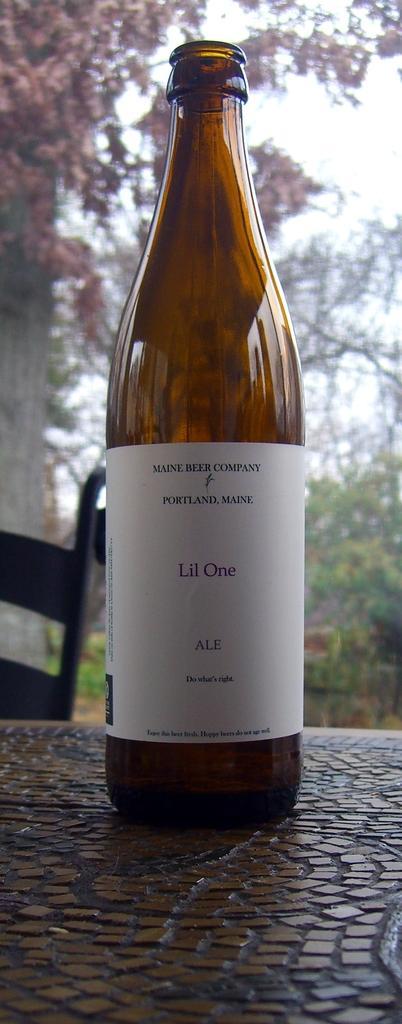Could you give a brief overview of what you see in this image? Here we can see a wine bottle on the table, and here is the tree. 